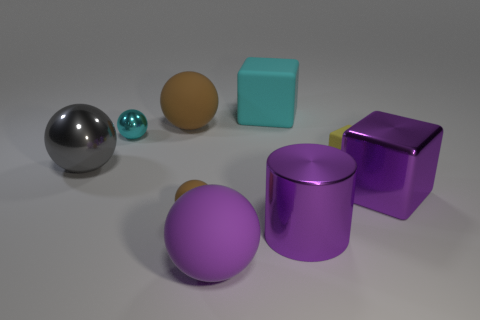What is the big sphere behind the large gray sphere made of?
Offer a very short reply. Rubber. What number of rubber objects are tiny brown spheres or gray blocks?
Your answer should be very brief. 1. Is there a yellow rubber thing that has the same size as the purple metallic cylinder?
Keep it short and to the point. No. Is the number of big cyan matte cubes in front of the large cyan object greater than the number of large blue rubber blocks?
Give a very brief answer. No. What number of tiny objects are either purple matte balls or purple cylinders?
Provide a succinct answer. 0. How many metallic things are the same shape as the cyan rubber object?
Your answer should be very brief. 1. There is a cyan object that is right of the big purple thing in front of the big shiny cylinder; what is its material?
Give a very brief answer. Rubber. There is a brown matte ball behind the cyan metal ball; what size is it?
Provide a short and direct response. Large. What number of blue things are tiny metallic spheres or metallic blocks?
Your answer should be very brief. 0. What is the material of the other large thing that is the same shape as the big cyan thing?
Your response must be concise. Metal. 